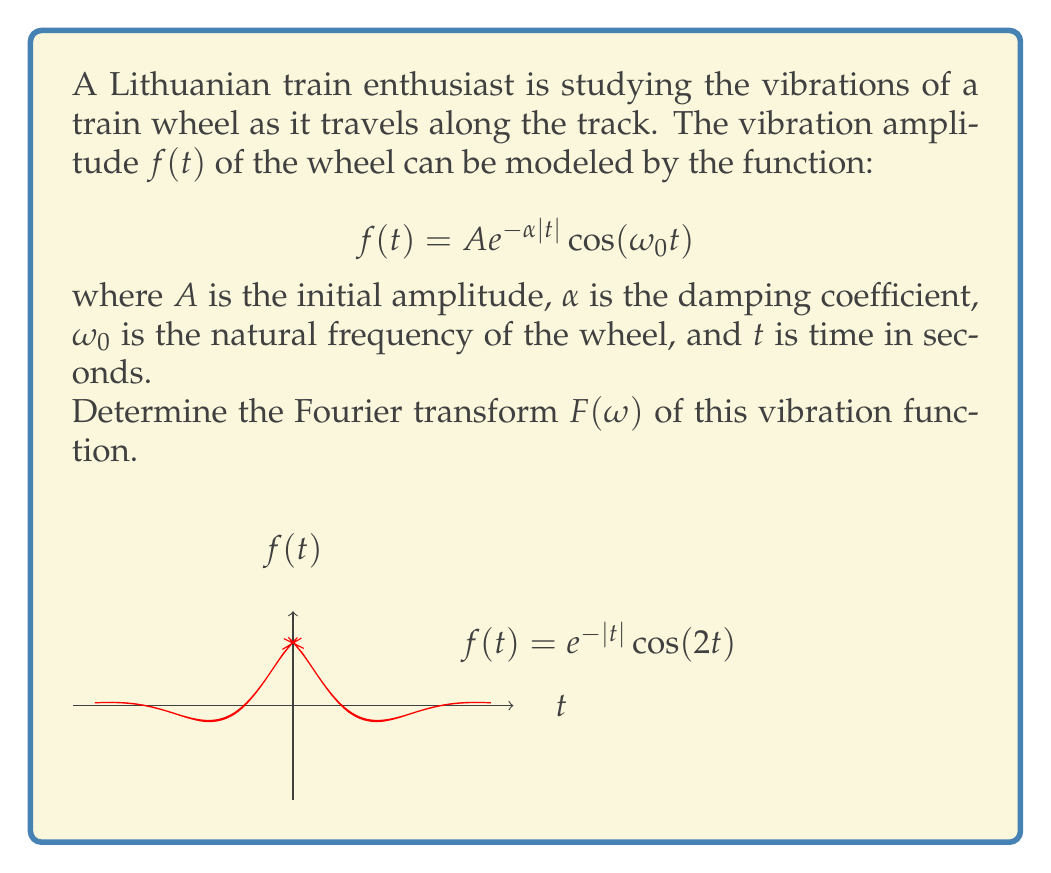What is the answer to this math problem? To find the Fourier transform of $f(t) = A e^{-\alpha|t|} \cos(\omega_0 t)$, we follow these steps:

1) The Fourier transform is defined as:
   $$F(\omega) = \int_{-\infty}^{\infty} f(t) e^{-i\omega t} dt$$

2) We can use Euler's formula to express the cosine function:
   $$\cos(\omega_0 t) = \frac{1}{2}(e^{i\omega_0 t} + e^{-i\omega_0 t})$$

3) Substituting this into our function:
   $$f(t) = \frac{A}{2} e^{-\alpha|t|} (e^{i\omega_0 t} + e^{-i\omega_0 t})$$

4) Now we can split the integral:
   $$F(\omega) = \frac{A}{2} \int_{-\infty}^{\infty} e^{-\alpha|t|} (e^{i\omega_0 t} + e^{-i\omega_0 t}) e^{-i\omega t} dt$$

5) This can be further split into:
   $$F(\omega) = \frac{A}{2} \int_{-\infty}^{\infty} e^{-\alpha|t|} e^{i(\omega_0-\omega) t} dt + \frac{A}{2} \int_{-\infty}^{\infty} e^{-\alpha|t|} e^{-i(\omega_0+\omega) t} dt$$

6) Each of these integrals is of the form:
   $$\int_{-\infty}^{\infty} e^{-\alpha|t|} e^{-i\beta t} dt = \frac{2\alpha}{\alpha^2 + \beta^2}$$

7) Applying this result to our integrals:
   $$F(\omega) = \frac{A}{2} \cdot \frac{2\alpha}{\alpha^2 + (\omega_0-\omega)^2} + \frac{A}{2} \cdot \frac{2\alpha}{\alpha^2 + (\omega_0+\omega)^2}$$

8) Simplifying:
   $$F(\omega) = A\alpha \left(\frac{1}{\alpha^2 + (\omega_0-\omega)^2} + \frac{1}{\alpha^2 + (\omega_0+\omega)^2}\right)$$

This is the Fourier transform of the given vibration function.
Answer: $$F(\omega) = A\alpha \left(\frac{1}{\alpha^2 + (\omega_0-\omega)^2} + \frac{1}{\alpha^2 + (\omega_0+\omega)^2}\right)$$ 